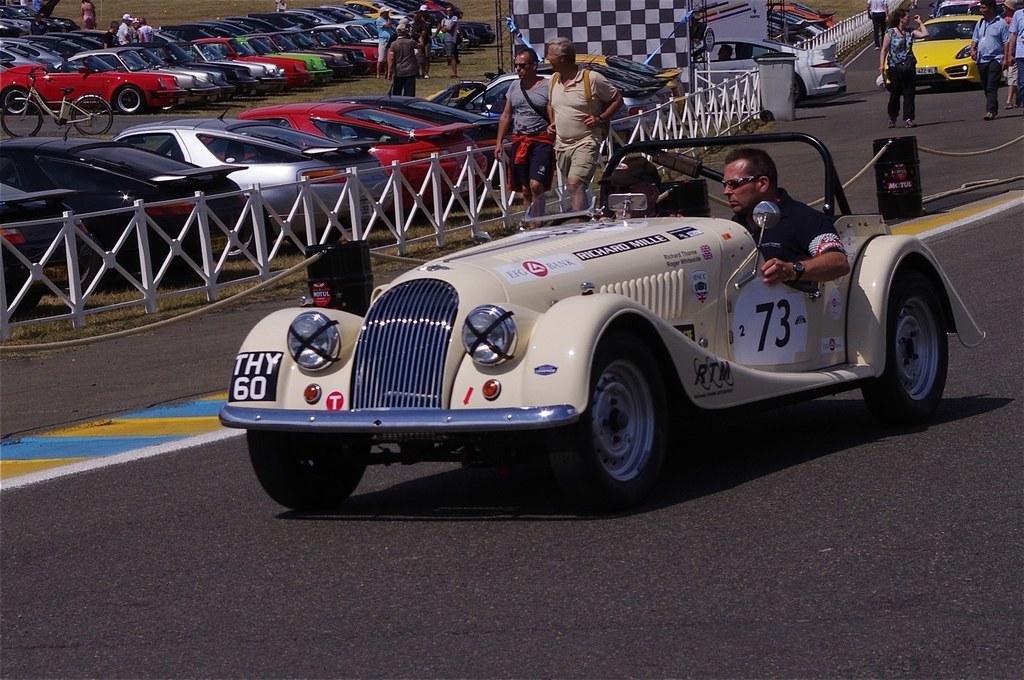Could you give a brief overview of what you see in this image? Here there are cars parked. A man is driving on the road and two persons are walking on the road. 